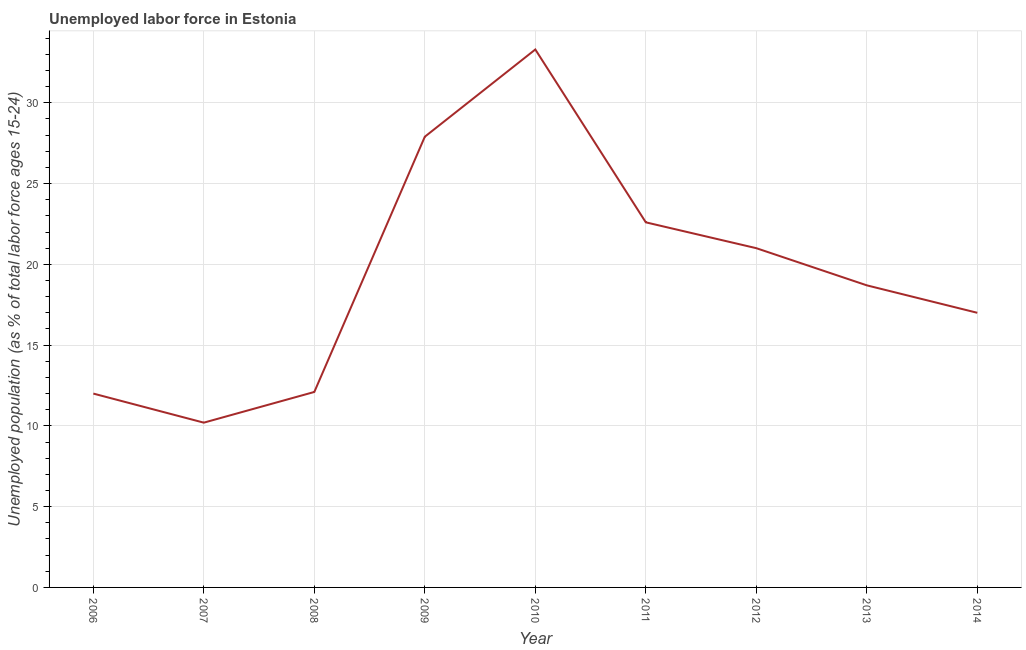What is the total unemployed youth population in 2009?
Provide a succinct answer. 27.9. Across all years, what is the maximum total unemployed youth population?
Provide a short and direct response. 33.3. Across all years, what is the minimum total unemployed youth population?
Make the answer very short. 10.2. In which year was the total unemployed youth population maximum?
Provide a short and direct response. 2010. What is the sum of the total unemployed youth population?
Keep it short and to the point. 174.8. What is the difference between the total unemployed youth population in 2007 and 2014?
Keep it short and to the point. -6.8. What is the average total unemployed youth population per year?
Ensure brevity in your answer.  19.42. What is the median total unemployed youth population?
Keep it short and to the point. 18.7. Do a majority of the years between 2010 and 2011 (inclusive) have total unemployed youth population greater than 9 %?
Your answer should be compact. Yes. What is the ratio of the total unemployed youth population in 2008 to that in 2014?
Give a very brief answer. 0.71. Is the difference between the total unemployed youth population in 2010 and 2012 greater than the difference between any two years?
Ensure brevity in your answer.  No. What is the difference between the highest and the second highest total unemployed youth population?
Your answer should be compact. 5.4. Is the sum of the total unemployed youth population in 2010 and 2013 greater than the maximum total unemployed youth population across all years?
Provide a succinct answer. Yes. What is the difference between the highest and the lowest total unemployed youth population?
Your answer should be very brief. 23.1. What is the difference between two consecutive major ticks on the Y-axis?
Make the answer very short. 5. Does the graph contain grids?
Your response must be concise. Yes. What is the title of the graph?
Offer a very short reply. Unemployed labor force in Estonia. What is the label or title of the X-axis?
Give a very brief answer. Year. What is the label or title of the Y-axis?
Offer a terse response. Unemployed population (as % of total labor force ages 15-24). What is the Unemployed population (as % of total labor force ages 15-24) in 2006?
Your answer should be very brief. 12. What is the Unemployed population (as % of total labor force ages 15-24) of 2007?
Your answer should be compact. 10.2. What is the Unemployed population (as % of total labor force ages 15-24) of 2008?
Offer a terse response. 12.1. What is the Unemployed population (as % of total labor force ages 15-24) of 2009?
Give a very brief answer. 27.9. What is the Unemployed population (as % of total labor force ages 15-24) of 2010?
Your answer should be compact. 33.3. What is the Unemployed population (as % of total labor force ages 15-24) of 2011?
Keep it short and to the point. 22.6. What is the Unemployed population (as % of total labor force ages 15-24) in 2012?
Offer a terse response. 21. What is the Unemployed population (as % of total labor force ages 15-24) of 2013?
Your answer should be very brief. 18.7. What is the difference between the Unemployed population (as % of total labor force ages 15-24) in 2006 and 2007?
Your response must be concise. 1.8. What is the difference between the Unemployed population (as % of total labor force ages 15-24) in 2006 and 2009?
Ensure brevity in your answer.  -15.9. What is the difference between the Unemployed population (as % of total labor force ages 15-24) in 2006 and 2010?
Your response must be concise. -21.3. What is the difference between the Unemployed population (as % of total labor force ages 15-24) in 2006 and 2011?
Provide a succinct answer. -10.6. What is the difference between the Unemployed population (as % of total labor force ages 15-24) in 2006 and 2013?
Offer a very short reply. -6.7. What is the difference between the Unemployed population (as % of total labor force ages 15-24) in 2007 and 2008?
Keep it short and to the point. -1.9. What is the difference between the Unemployed population (as % of total labor force ages 15-24) in 2007 and 2009?
Provide a short and direct response. -17.7. What is the difference between the Unemployed population (as % of total labor force ages 15-24) in 2007 and 2010?
Your answer should be very brief. -23.1. What is the difference between the Unemployed population (as % of total labor force ages 15-24) in 2007 and 2011?
Your response must be concise. -12.4. What is the difference between the Unemployed population (as % of total labor force ages 15-24) in 2008 and 2009?
Provide a succinct answer. -15.8. What is the difference between the Unemployed population (as % of total labor force ages 15-24) in 2008 and 2010?
Provide a succinct answer. -21.2. What is the difference between the Unemployed population (as % of total labor force ages 15-24) in 2008 and 2011?
Ensure brevity in your answer.  -10.5. What is the difference between the Unemployed population (as % of total labor force ages 15-24) in 2008 and 2012?
Offer a terse response. -8.9. What is the difference between the Unemployed population (as % of total labor force ages 15-24) in 2008 and 2013?
Give a very brief answer. -6.6. What is the difference between the Unemployed population (as % of total labor force ages 15-24) in 2009 and 2014?
Keep it short and to the point. 10.9. What is the difference between the Unemployed population (as % of total labor force ages 15-24) in 2010 and 2012?
Make the answer very short. 12.3. What is the difference between the Unemployed population (as % of total labor force ages 15-24) in 2010 and 2014?
Give a very brief answer. 16.3. What is the difference between the Unemployed population (as % of total labor force ages 15-24) in 2011 and 2014?
Keep it short and to the point. 5.6. What is the difference between the Unemployed population (as % of total labor force ages 15-24) in 2012 and 2014?
Keep it short and to the point. 4. What is the difference between the Unemployed population (as % of total labor force ages 15-24) in 2013 and 2014?
Provide a short and direct response. 1.7. What is the ratio of the Unemployed population (as % of total labor force ages 15-24) in 2006 to that in 2007?
Offer a terse response. 1.18. What is the ratio of the Unemployed population (as % of total labor force ages 15-24) in 2006 to that in 2009?
Provide a succinct answer. 0.43. What is the ratio of the Unemployed population (as % of total labor force ages 15-24) in 2006 to that in 2010?
Provide a short and direct response. 0.36. What is the ratio of the Unemployed population (as % of total labor force ages 15-24) in 2006 to that in 2011?
Your answer should be compact. 0.53. What is the ratio of the Unemployed population (as % of total labor force ages 15-24) in 2006 to that in 2012?
Your answer should be very brief. 0.57. What is the ratio of the Unemployed population (as % of total labor force ages 15-24) in 2006 to that in 2013?
Offer a very short reply. 0.64. What is the ratio of the Unemployed population (as % of total labor force ages 15-24) in 2006 to that in 2014?
Ensure brevity in your answer.  0.71. What is the ratio of the Unemployed population (as % of total labor force ages 15-24) in 2007 to that in 2008?
Make the answer very short. 0.84. What is the ratio of the Unemployed population (as % of total labor force ages 15-24) in 2007 to that in 2009?
Your answer should be very brief. 0.37. What is the ratio of the Unemployed population (as % of total labor force ages 15-24) in 2007 to that in 2010?
Give a very brief answer. 0.31. What is the ratio of the Unemployed population (as % of total labor force ages 15-24) in 2007 to that in 2011?
Make the answer very short. 0.45. What is the ratio of the Unemployed population (as % of total labor force ages 15-24) in 2007 to that in 2012?
Give a very brief answer. 0.49. What is the ratio of the Unemployed population (as % of total labor force ages 15-24) in 2007 to that in 2013?
Offer a terse response. 0.55. What is the ratio of the Unemployed population (as % of total labor force ages 15-24) in 2008 to that in 2009?
Your response must be concise. 0.43. What is the ratio of the Unemployed population (as % of total labor force ages 15-24) in 2008 to that in 2010?
Provide a short and direct response. 0.36. What is the ratio of the Unemployed population (as % of total labor force ages 15-24) in 2008 to that in 2011?
Give a very brief answer. 0.54. What is the ratio of the Unemployed population (as % of total labor force ages 15-24) in 2008 to that in 2012?
Offer a very short reply. 0.58. What is the ratio of the Unemployed population (as % of total labor force ages 15-24) in 2008 to that in 2013?
Offer a very short reply. 0.65. What is the ratio of the Unemployed population (as % of total labor force ages 15-24) in 2008 to that in 2014?
Your response must be concise. 0.71. What is the ratio of the Unemployed population (as % of total labor force ages 15-24) in 2009 to that in 2010?
Your answer should be very brief. 0.84. What is the ratio of the Unemployed population (as % of total labor force ages 15-24) in 2009 to that in 2011?
Offer a terse response. 1.24. What is the ratio of the Unemployed population (as % of total labor force ages 15-24) in 2009 to that in 2012?
Your answer should be very brief. 1.33. What is the ratio of the Unemployed population (as % of total labor force ages 15-24) in 2009 to that in 2013?
Offer a very short reply. 1.49. What is the ratio of the Unemployed population (as % of total labor force ages 15-24) in 2009 to that in 2014?
Keep it short and to the point. 1.64. What is the ratio of the Unemployed population (as % of total labor force ages 15-24) in 2010 to that in 2011?
Your answer should be compact. 1.47. What is the ratio of the Unemployed population (as % of total labor force ages 15-24) in 2010 to that in 2012?
Offer a very short reply. 1.59. What is the ratio of the Unemployed population (as % of total labor force ages 15-24) in 2010 to that in 2013?
Your answer should be very brief. 1.78. What is the ratio of the Unemployed population (as % of total labor force ages 15-24) in 2010 to that in 2014?
Your answer should be very brief. 1.96. What is the ratio of the Unemployed population (as % of total labor force ages 15-24) in 2011 to that in 2012?
Your answer should be very brief. 1.08. What is the ratio of the Unemployed population (as % of total labor force ages 15-24) in 2011 to that in 2013?
Give a very brief answer. 1.21. What is the ratio of the Unemployed population (as % of total labor force ages 15-24) in 2011 to that in 2014?
Give a very brief answer. 1.33. What is the ratio of the Unemployed population (as % of total labor force ages 15-24) in 2012 to that in 2013?
Ensure brevity in your answer.  1.12. What is the ratio of the Unemployed population (as % of total labor force ages 15-24) in 2012 to that in 2014?
Give a very brief answer. 1.24. 